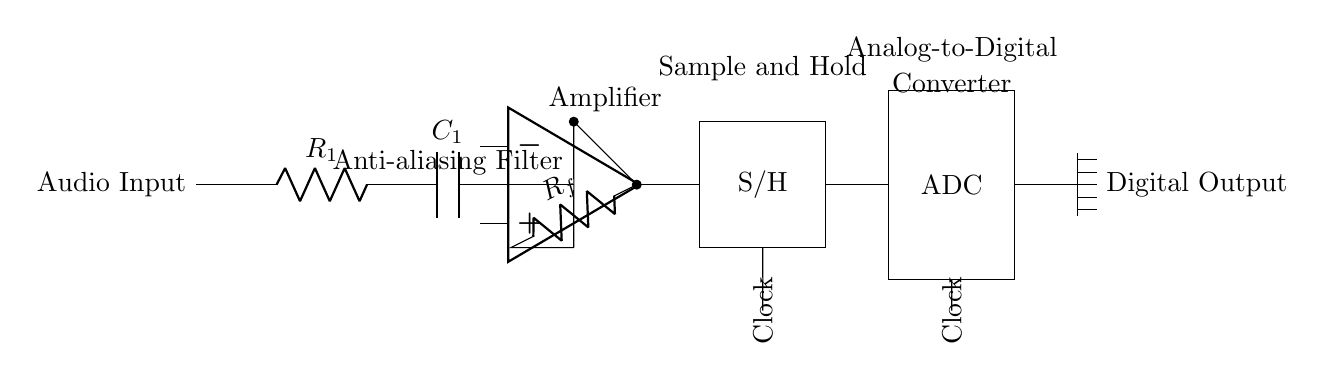What is the purpose of the component labeled S/H? The S/H component stands for Sample and Hold, which captures and holds an analog signal value at a specific point in time during the conversion process to digital.
Answer: Sample and Hold What component follows the anti-aliasing filter? After the anti-aliasing filter, the amplifier component is positioned to strengthen the audio signal before processing.
Answer: Amplifier What does ADC stand for? ADC stands for Analog-to-Digital Converter, which is responsible for converting the continuous analog signal into a discrete digital format.
Answer: Analog-to-Digital Converter How many resistors are present in the circuit? There are two resistors in the circuit: one labeled R1 and one labeled Rf, which are used for signal conditioning and feedback respectively.
Answer: Two What is the main function of the audio input in this circuit? The audio input serves as the starting point for the circuit, where the analog audio signal is introduced for further processing into a digital format.
Answer: Audio Input What role does the clock play in this circuit? The clock provides timing signals that synchronize the sampling and conversion of the analog signal into digital data, ensuring accurate representation of the signal.
Answer: Timing Signals 